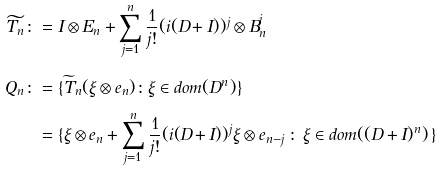<formula> <loc_0><loc_0><loc_500><loc_500>\widetilde { T _ { n } } \colon & = I \otimes E _ { n } + \sum _ { j = 1 } ^ { n } \frac { 1 } { j ! } ( i ( D + I ) ) ^ { j } \otimes B _ { n } ^ { j } \\ Q _ { n } \colon & = \{ \widetilde { T } _ { n } ( \xi \otimes e _ { n } ) \colon \xi \in d o m ( D ^ { n } ) \} \\ & = \{ \xi \otimes e _ { n } + \sum _ { j = 1 } ^ { n } \frac { 1 } { j ! } ( i ( D + I ) ) ^ { j } \xi \otimes e _ { n - j } \, \colon \, \xi \in d o m ( ( D + I ) ^ { n } ) \, \}</formula> 